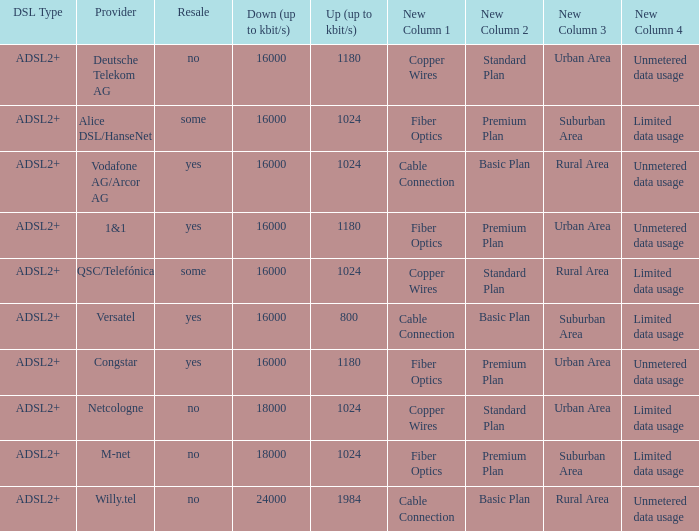How many providers are there where the resale category is yes and bandwith is up is 1024? 1.0. 